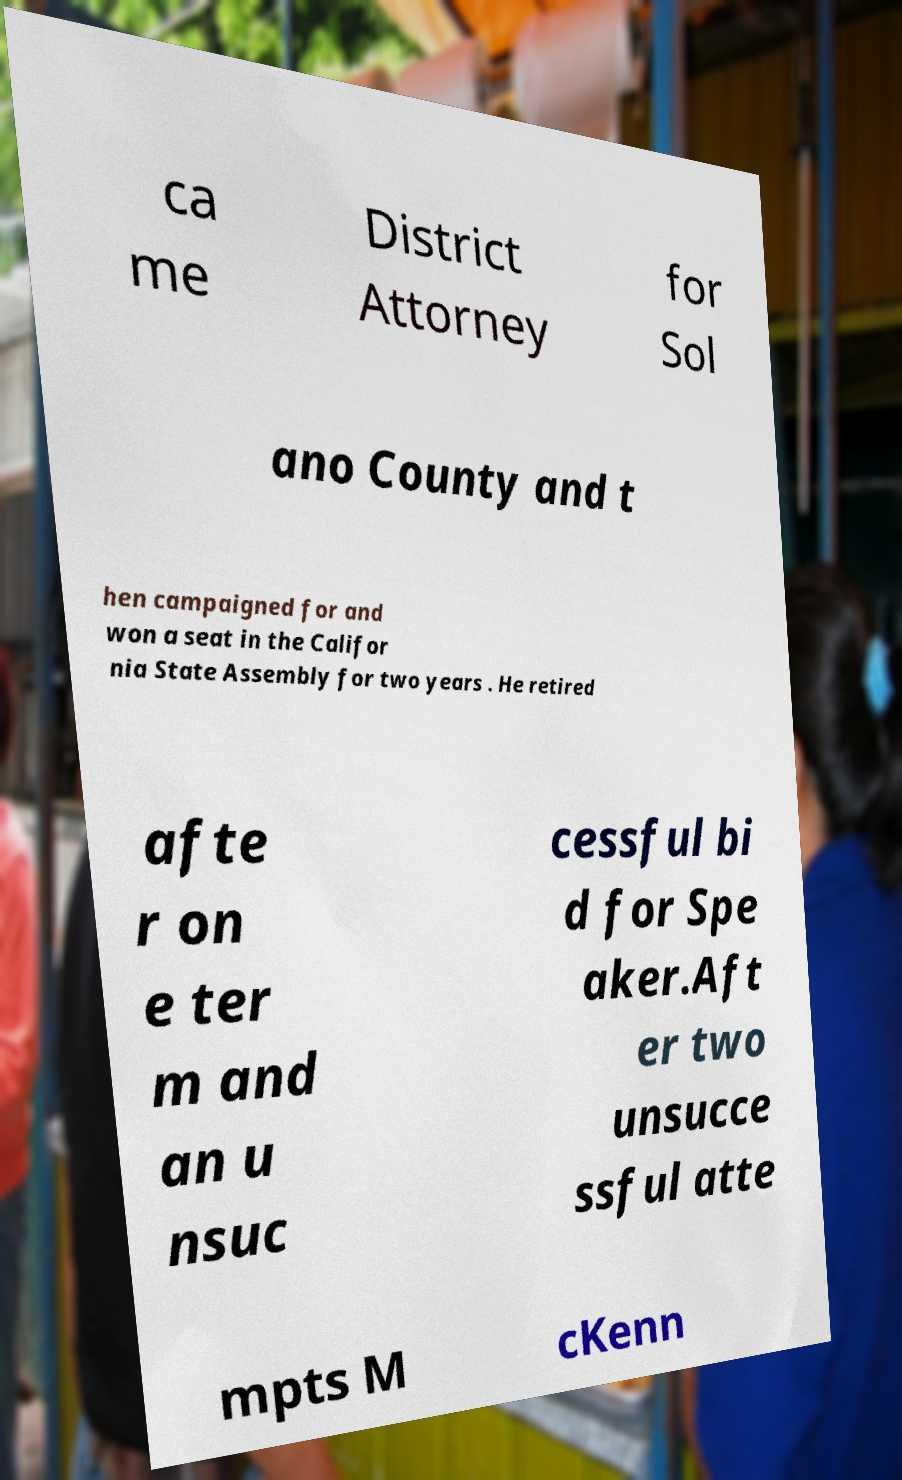Could you extract and type out the text from this image? ca me District Attorney for Sol ano County and t hen campaigned for and won a seat in the Califor nia State Assembly for two years . He retired afte r on e ter m and an u nsuc cessful bi d for Spe aker.Aft er two unsucce ssful atte mpts M cKenn 